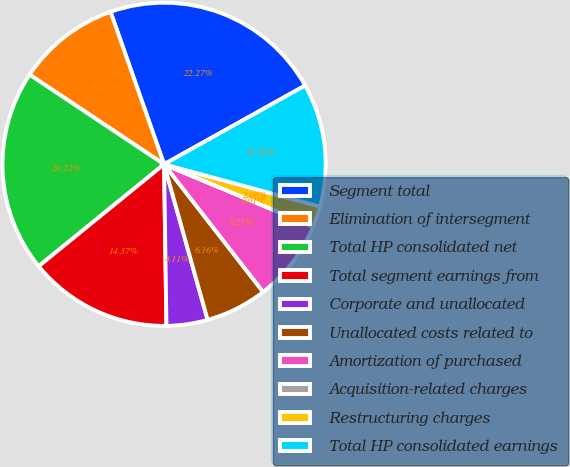<chart> <loc_0><loc_0><loc_500><loc_500><pie_chart><fcel>Segment total<fcel>Elimination of intersegment<fcel>Total HP consolidated net<fcel>Total segment earnings from<fcel>Corporate and unallocated<fcel>Unallocated costs related to<fcel>Amortization of purchased<fcel>Acquisition-related charges<fcel>Restructuring charges<fcel>Total HP consolidated earnings<nl><fcel>22.27%<fcel>10.27%<fcel>20.22%<fcel>14.37%<fcel>4.11%<fcel>6.16%<fcel>8.21%<fcel>0.01%<fcel>2.06%<fcel>12.32%<nl></chart> 